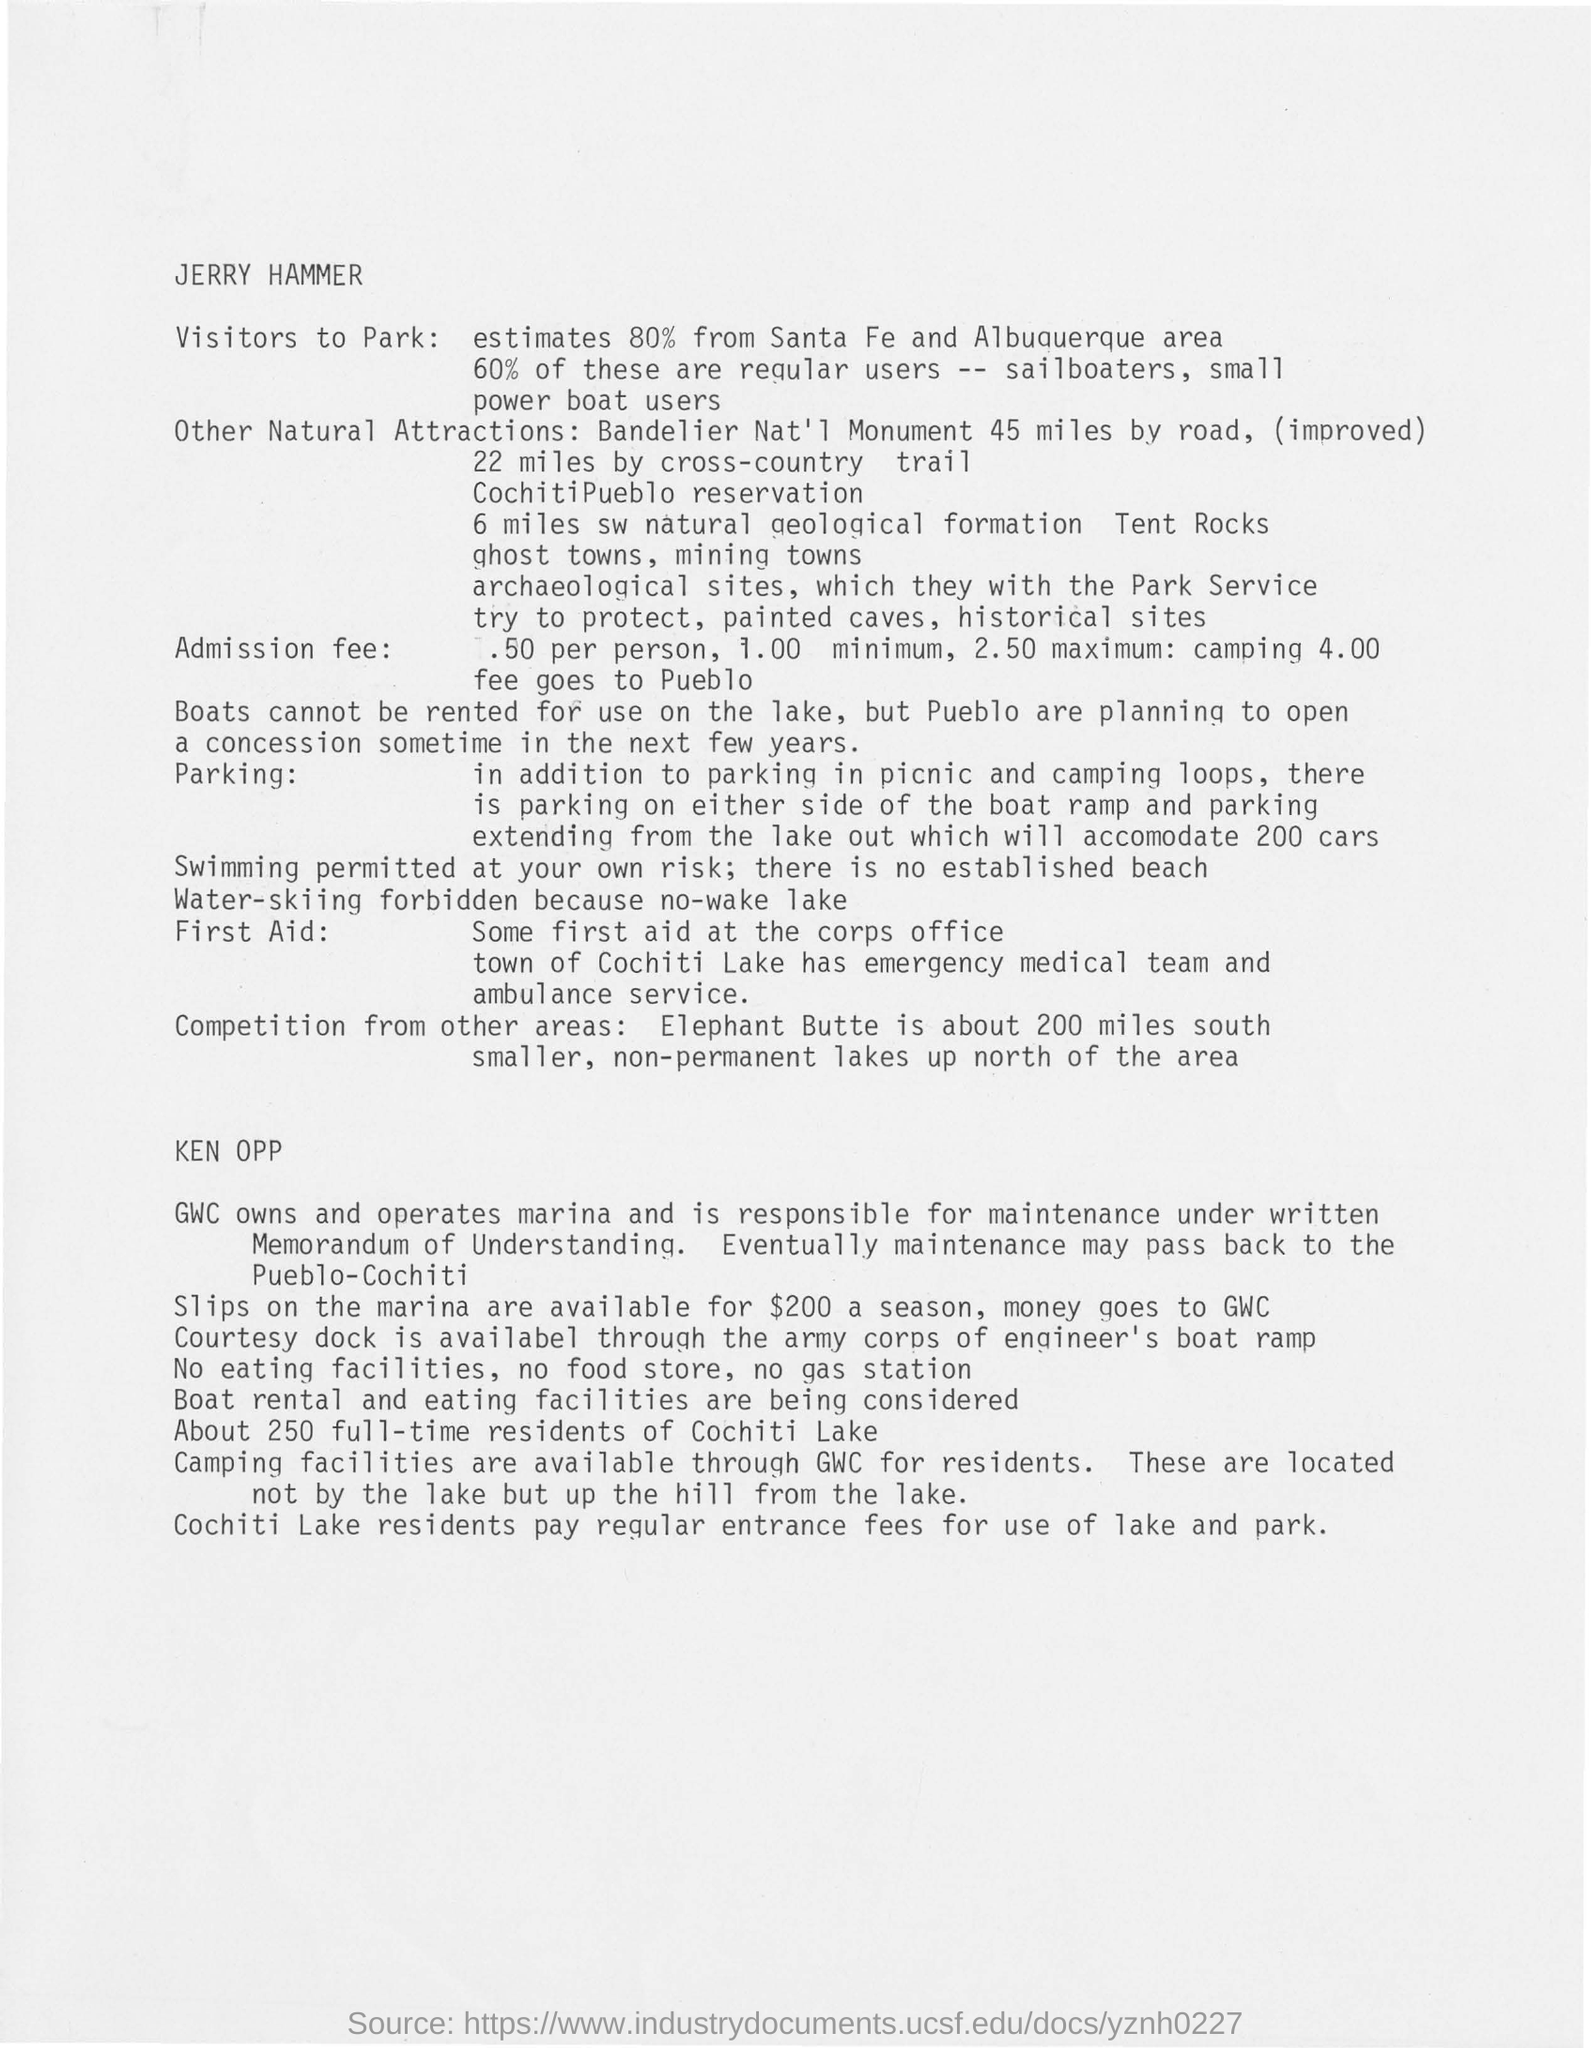How many % of Visitors estimate from Santa Fe and Albuquerque area?
Offer a terse response. 80%. Where is the first aid available?
Offer a very short reply. At the corps office town of Cochiti Lake has emergency Medical team and ambulance service. 